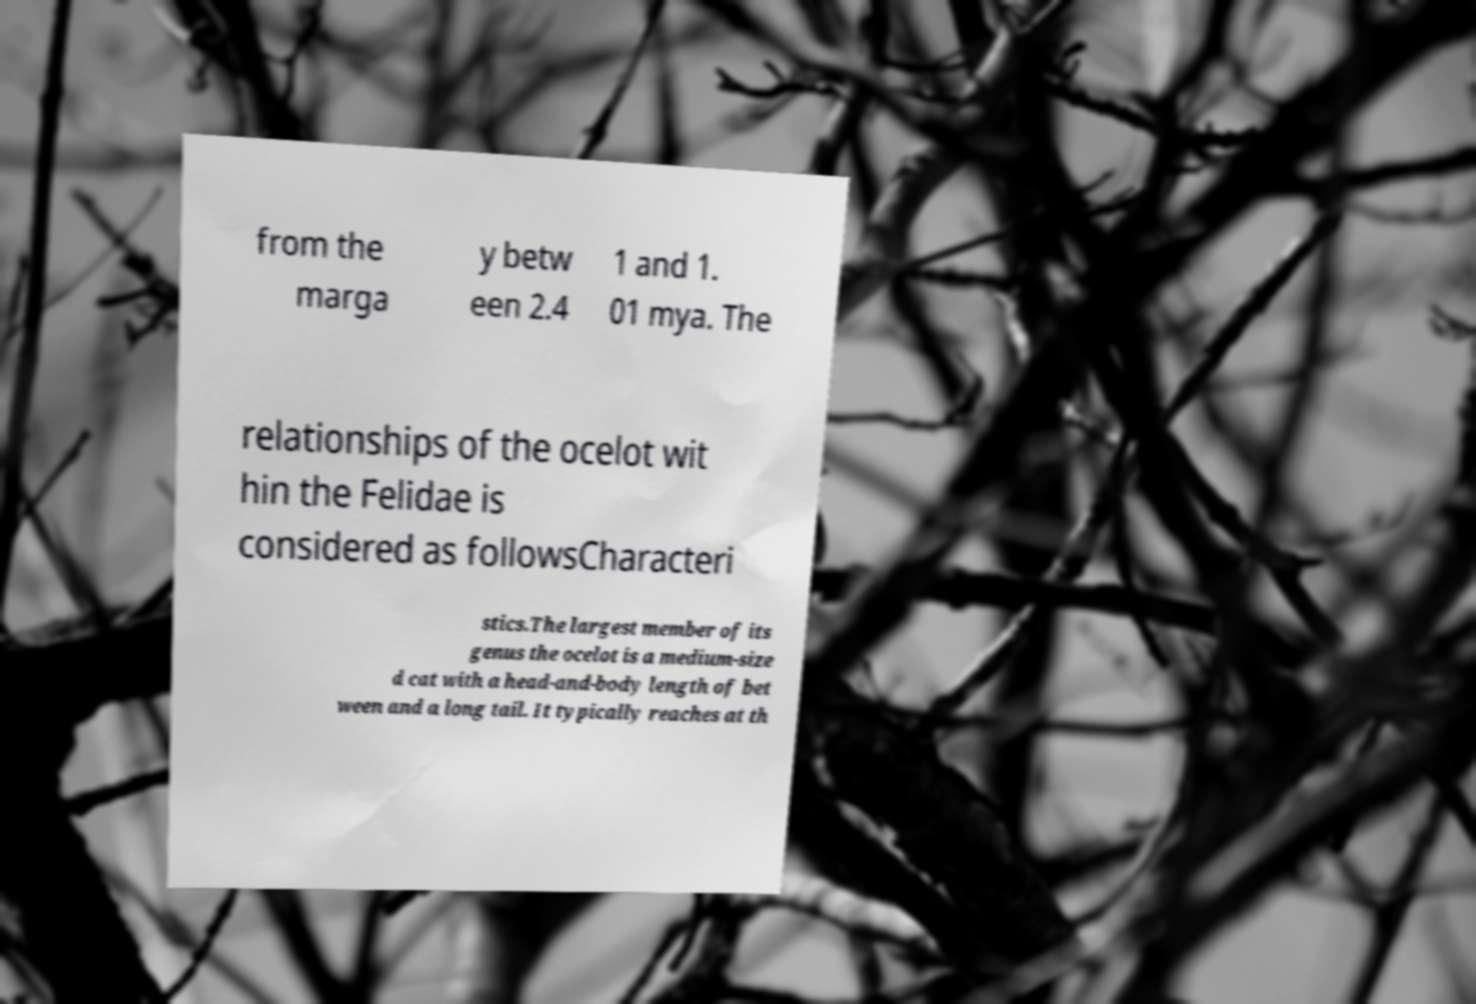Please read and relay the text visible in this image. What does it say? from the marga y betw een 2.4 1 and 1. 01 mya. The relationships of the ocelot wit hin the Felidae is considered as followsCharacteri stics.The largest member of its genus the ocelot is a medium-size d cat with a head-and-body length of bet ween and a long tail. It typically reaches at th 